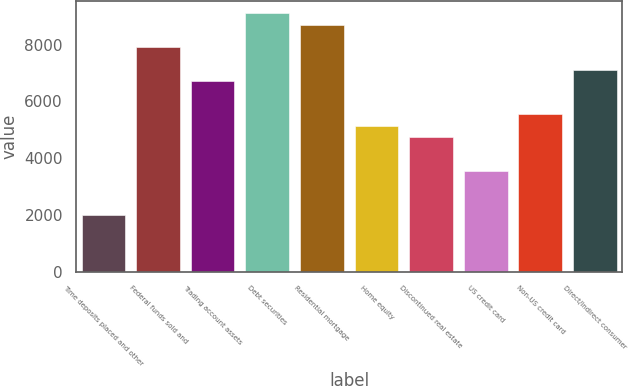Convert chart. <chart><loc_0><loc_0><loc_500><loc_500><bar_chart><fcel>Time deposits placed and other<fcel>Federal funds sold and<fcel>Trading account assets<fcel>Debt securities<fcel>Residential mortgage<fcel>Home equity<fcel>Discontinued real estate<fcel>US credit card<fcel>Non-US credit card<fcel>Direct/Indirect consumer<nl><fcel>1980<fcel>7917<fcel>6729.6<fcel>9104.4<fcel>8708.6<fcel>5146.4<fcel>4750.6<fcel>3563.2<fcel>5542.2<fcel>7125.4<nl></chart> 